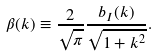Convert formula to latex. <formula><loc_0><loc_0><loc_500><loc_500>\beta ( k ) \equiv \frac { 2 } { \sqrt { \pi } } \frac { b _ { I } ( k ) } { \sqrt { 1 + k ^ { 2 } } } .</formula> 